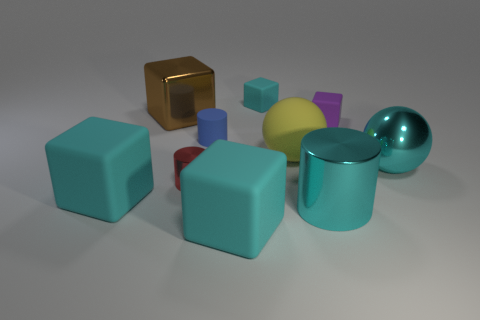Subtract all green balls. How many cyan cubes are left? 3 Subtract all cyan cylinders. How many cylinders are left? 2 Subtract all brown blocks. How many blocks are left? 4 Subtract 1 cylinders. How many cylinders are left? 2 Subtract all cylinders. How many objects are left? 7 Add 3 tiny yellow objects. How many tiny yellow objects exist? 3 Subtract 0 purple cylinders. How many objects are left? 10 Subtract all gray cylinders. Subtract all cyan blocks. How many cylinders are left? 3 Subtract all tiny red cylinders. Subtract all large shiny things. How many objects are left? 6 Add 8 large spheres. How many large spheres are left? 10 